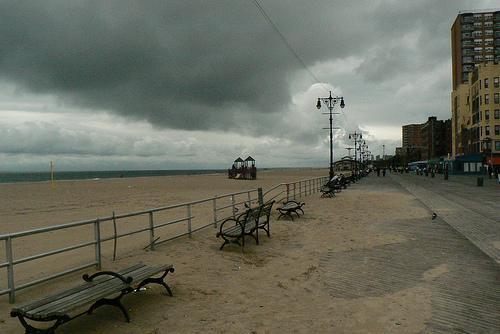How many street lights are there?
Give a very brief answer. 6. 